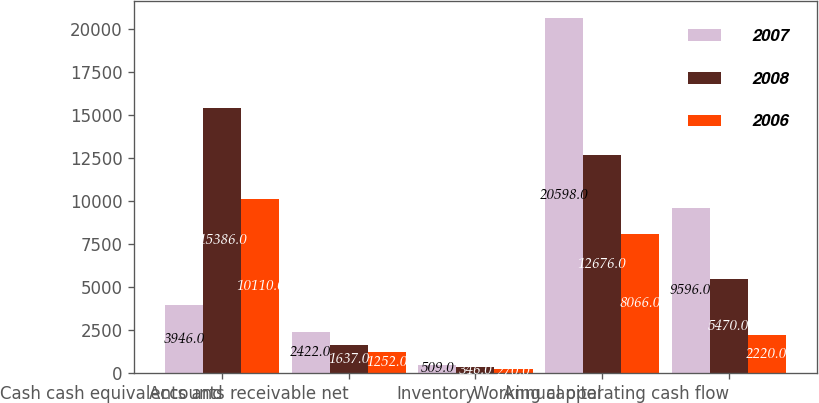Convert chart to OTSL. <chart><loc_0><loc_0><loc_500><loc_500><stacked_bar_chart><ecel><fcel>Cash cash equivalents and<fcel>Accounts receivable net<fcel>Inventory<fcel>Working capital<fcel>Annual operating cash flow<nl><fcel>2007<fcel>3946<fcel>2422<fcel>509<fcel>20598<fcel>9596<nl><fcel>2008<fcel>15386<fcel>1637<fcel>346<fcel>12676<fcel>5470<nl><fcel>2006<fcel>10110<fcel>1252<fcel>270<fcel>8066<fcel>2220<nl></chart> 